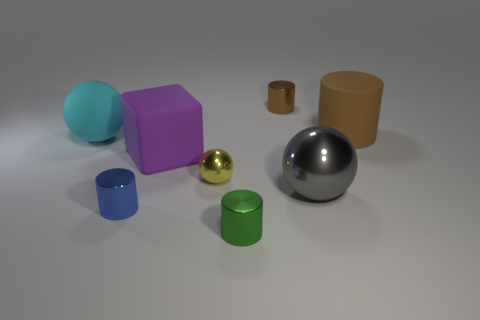Add 2 matte cylinders. How many objects exist? 10 Subtract all spheres. How many objects are left? 5 Add 8 tiny brown shiny cylinders. How many tiny brown shiny cylinders are left? 9 Add 8 large green metal spheres. How many large green metal spheres exist? 8 Subtract 1 green cylinders. How many objects are left? 7 Subtract all blue cylinders. Subtract all gray metallic things. How many objects are left? 6 